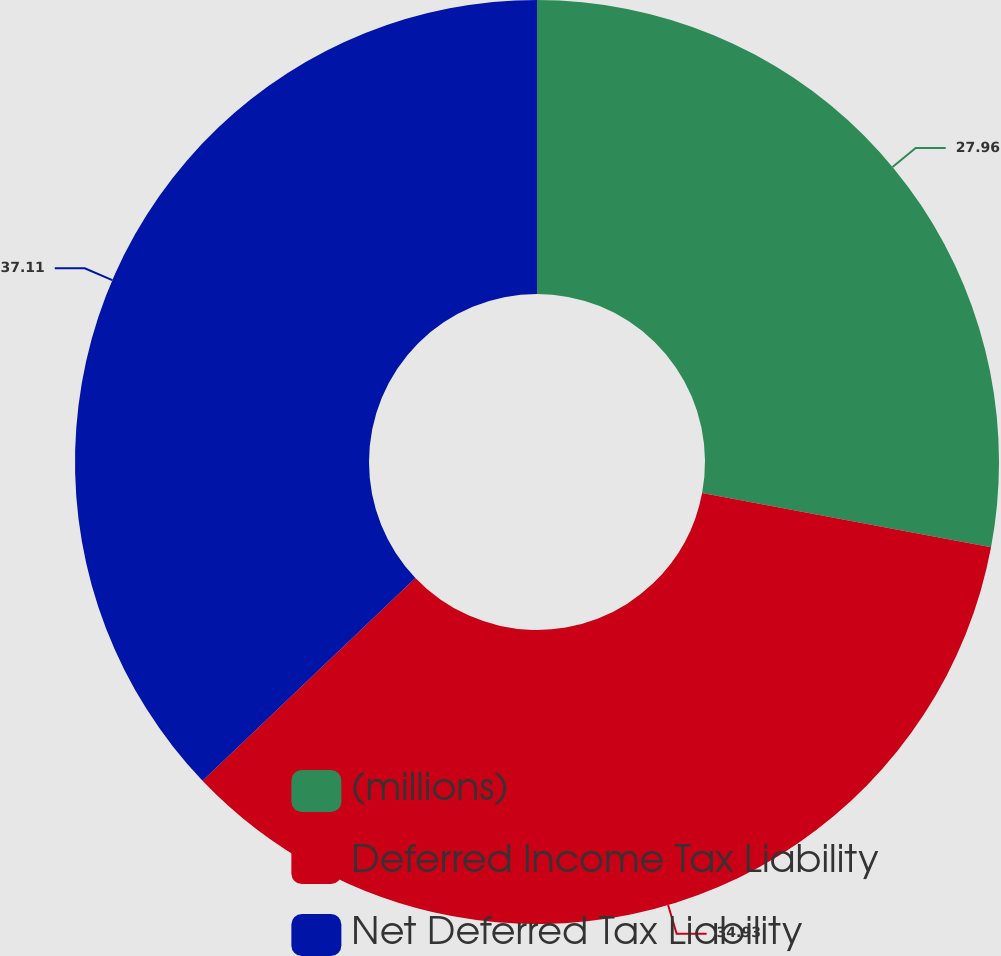Convert chart. <chart><loc_0><loc_0><loc_500><loc_500><pie_chart><fcel>(millions)<fcel>Deferred Income Tax Liability<fcel>Net Deferred Tax Liability<nl><fcel>27.96%<fcel>34.93%<fcel>37.12%<nl></chart> 